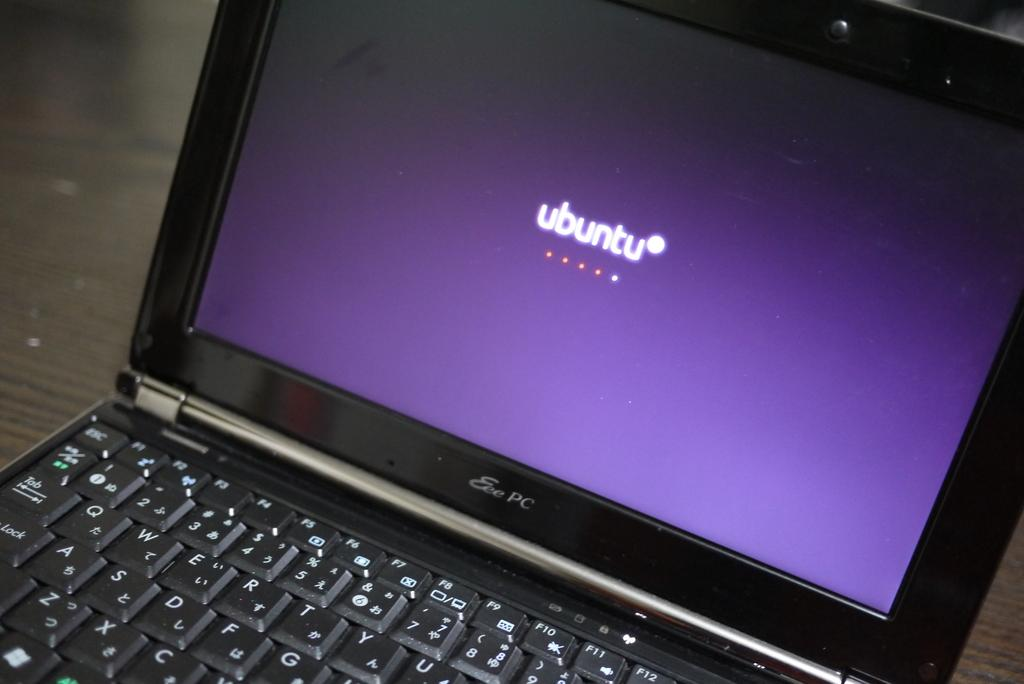What electronic device is visible in the image? There is a laptop in the image. What color is the laptop? The laptop is black in color. Where is the laptop located in the image? The laptop is on a table. What type of porter is assisting with the voyage or discovery in the image? There is no porter, voyage, or discovery present in the image; it features a black laptop on a table. 